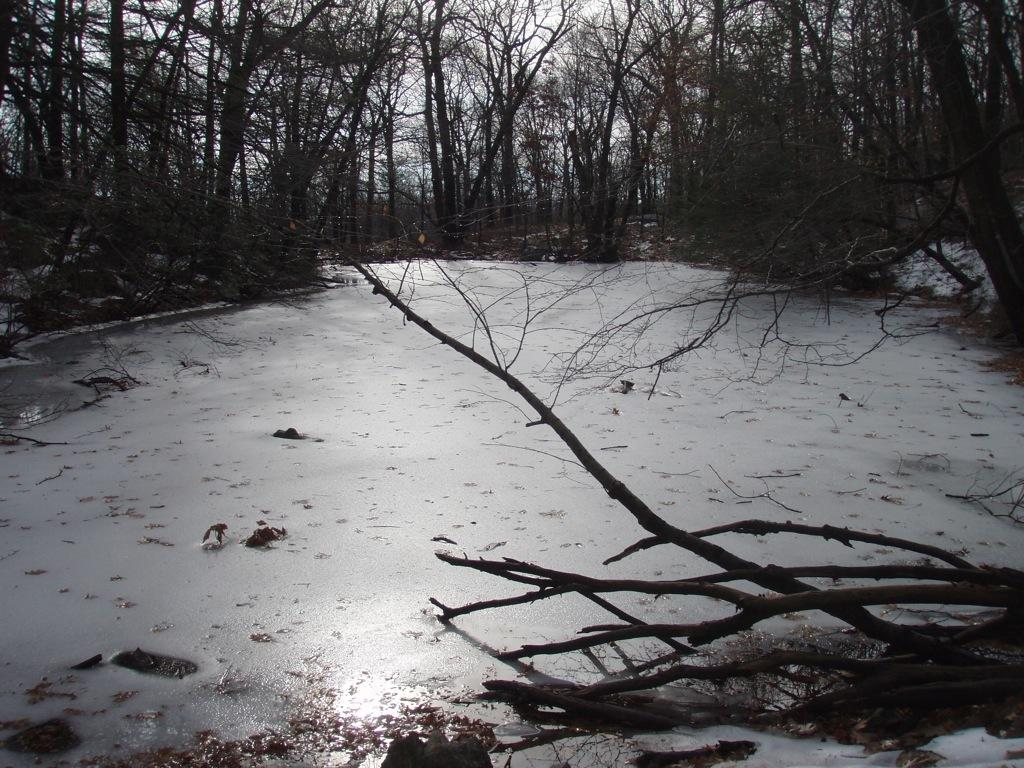What type of vegetation can be seen in the image? There are trees in the image. What is visible at the top of the image? The sky is visible at the top of the image. What type of insect can be seen crawling on the spot in the image? There is no insect or spot present in the image; it only features trees and the sky. 